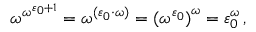<formula> <loc_0><loc_0><loc_500><loc_500>\omega ^ { \omega ^ { \varepsilon _ { 0 } + 1 } } = \omega ^ { ( \varepsilon _ { 0 } \cdot \omega ) } = { ( \omega ^ { \varepsilon _ { 0 } } ) } ^ { \omega } = \varepsilon _ { 0 } ^ { \omega } \, ,</formula> 